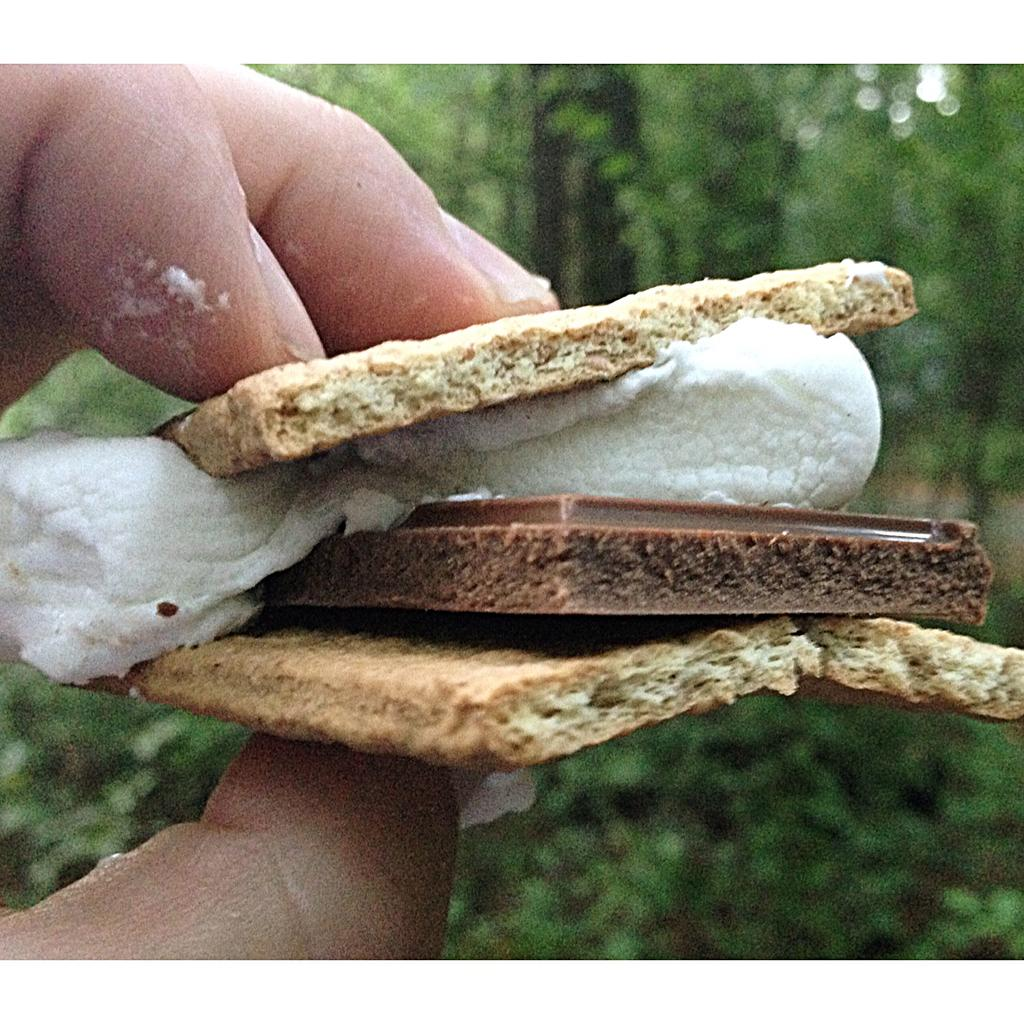What is the main subject in the center of the image? There is a bread in the center of the image. Who is holding the bread in the image? The bread is in a person's hand. What can be seen in the background of the image? There are trees in the background of the image. Can you see any clovers growing near the bread in the image? There are no clovers visible in the image. How many passengers are present in the image? There is no reference to passengers in the image, as it features a person holding bread and trees in the background. 